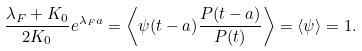Convert formula to latex. <formula><loc_0><loc_0><loc_500><loc_500>\frac { \lambda _ { F } + K _ { 0 } } { 2 K _ { 0 } } e ^ { \lambda _ { F } a } = \left \langle \psi ( t - a ) \frac { P ( t - a ) } { P ( t ) } \right \rangle = \langle \psi \rangle = 1 .</formula> 